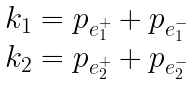Convert formula to latex. <formula><loc_0><loc_0><loc_500><loc_500>\begin{array} { l } k _ { 1 } = p _ { e ^ { + } _ { 1 } } + p _ { e ^ { - } _ { 1 } } \\ k _ { 2 } = p _ { e ^ { + } _ { 2 } } + p _ { e ^ { - } _ { 2 } } \end{array}</formula> 